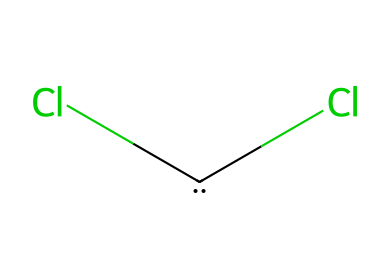What is the molecular formula of dichlorocarbene? The chemical structure shows one carbon atom and two chlorine atoms attached to it. The molecular formula is derived from counting these atoms.
Answer: CCl2 How many valence electrons does the carbon atom in dichlorocarbene have? Carbon typically has four valence electrons. In this molecule, the carbon atom is bonded to two chlorine atoms, not affecting its original valence count.
Answer: 4 What type of hybridization does the carbon in dichlorocarbene exhibit? The carbon atom in dichlorocarbene has two chlorine substituents and one vacant p-orbital, indicating sp2 hybridization.
Answer: sp2 What is the role of dichlorocarbene in food contaminant analysis? Dichlorocarbene is a reactive intermediate used to form various derivatives, helping identify specific contaminants during analysis.
Answer: reactive intermediate What can be inferred about the stability of dichlorocarbene? Dichlorocarbene is considered to be a relatively unstable species due to its electronic configuration, particularly the presence of a lone pair and a vacant p-orbital.
Answer: unstable How many total atoms are present in dichlorocarbene? The molecular structure reveals one carbon atom and two chlorine atoms, totaling three atoms in the molecule.
Answer: 3 